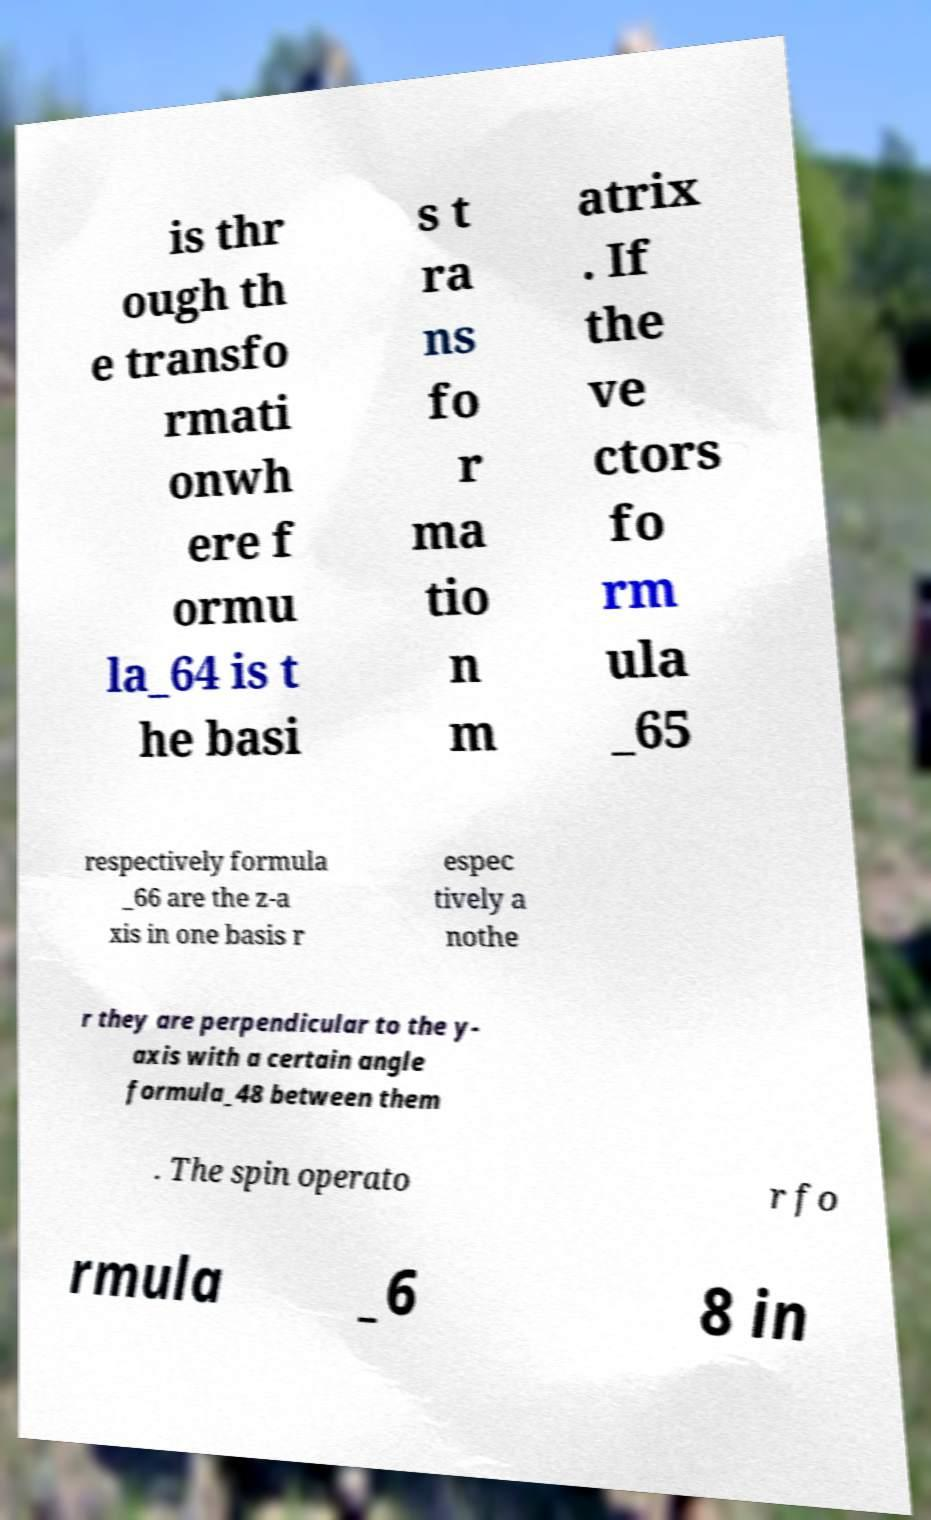There's text embedded in this image that I need extracted. Can you transcribe it verbatim? is thr ough th e transfo rmati onwh ere f ormu la_64 is t he basi s t ra ns fo r ma tio n m atrix . If the ve ctors fo rm ula _65 respectively formula _66 are the z-a xis in one basis r espec tively a nothe r they are perpendicular to the y- axis with a certain angle formula_48 between them . The spin operato r fo rmula _6 8 in 